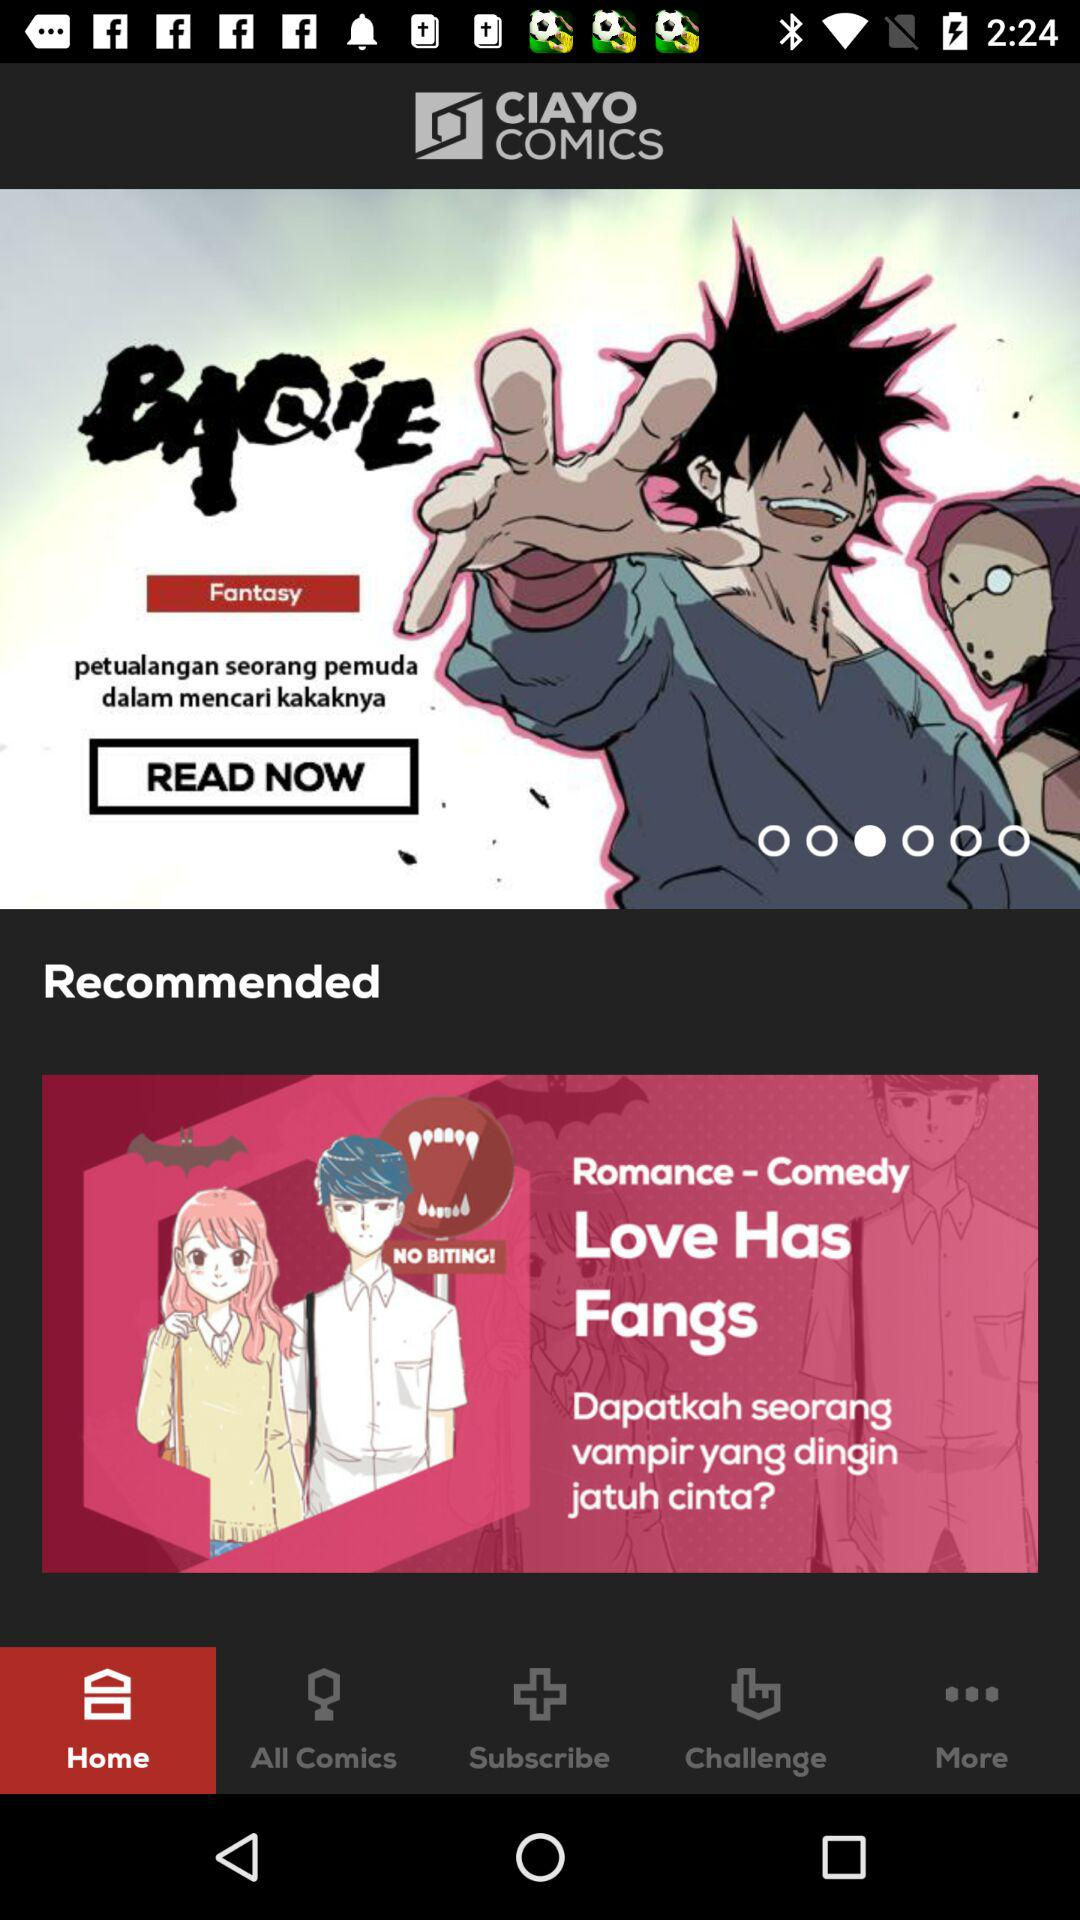What is the application name? The application name is "CIAYO COMICS". 